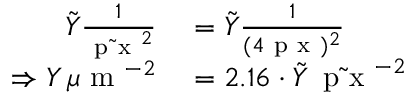<formula> <loc_0><loc_0><loc_500><loc_500>\begin{array} { r l } { \tilde { Y } \frac { 1 } { \tilde { p x } ^ { 2 } } } & = \tilde { Y } \frac { 1 } { ( 4 p x ) ^ { 2 } } } \\ { \Rightarrow Y \, \mu m ^ { - 2 } } & = 2 . 1 6 \cdot \tilde { Y } \, \tilde { p x } ^ { - 2 } } \end{array}</formula> 